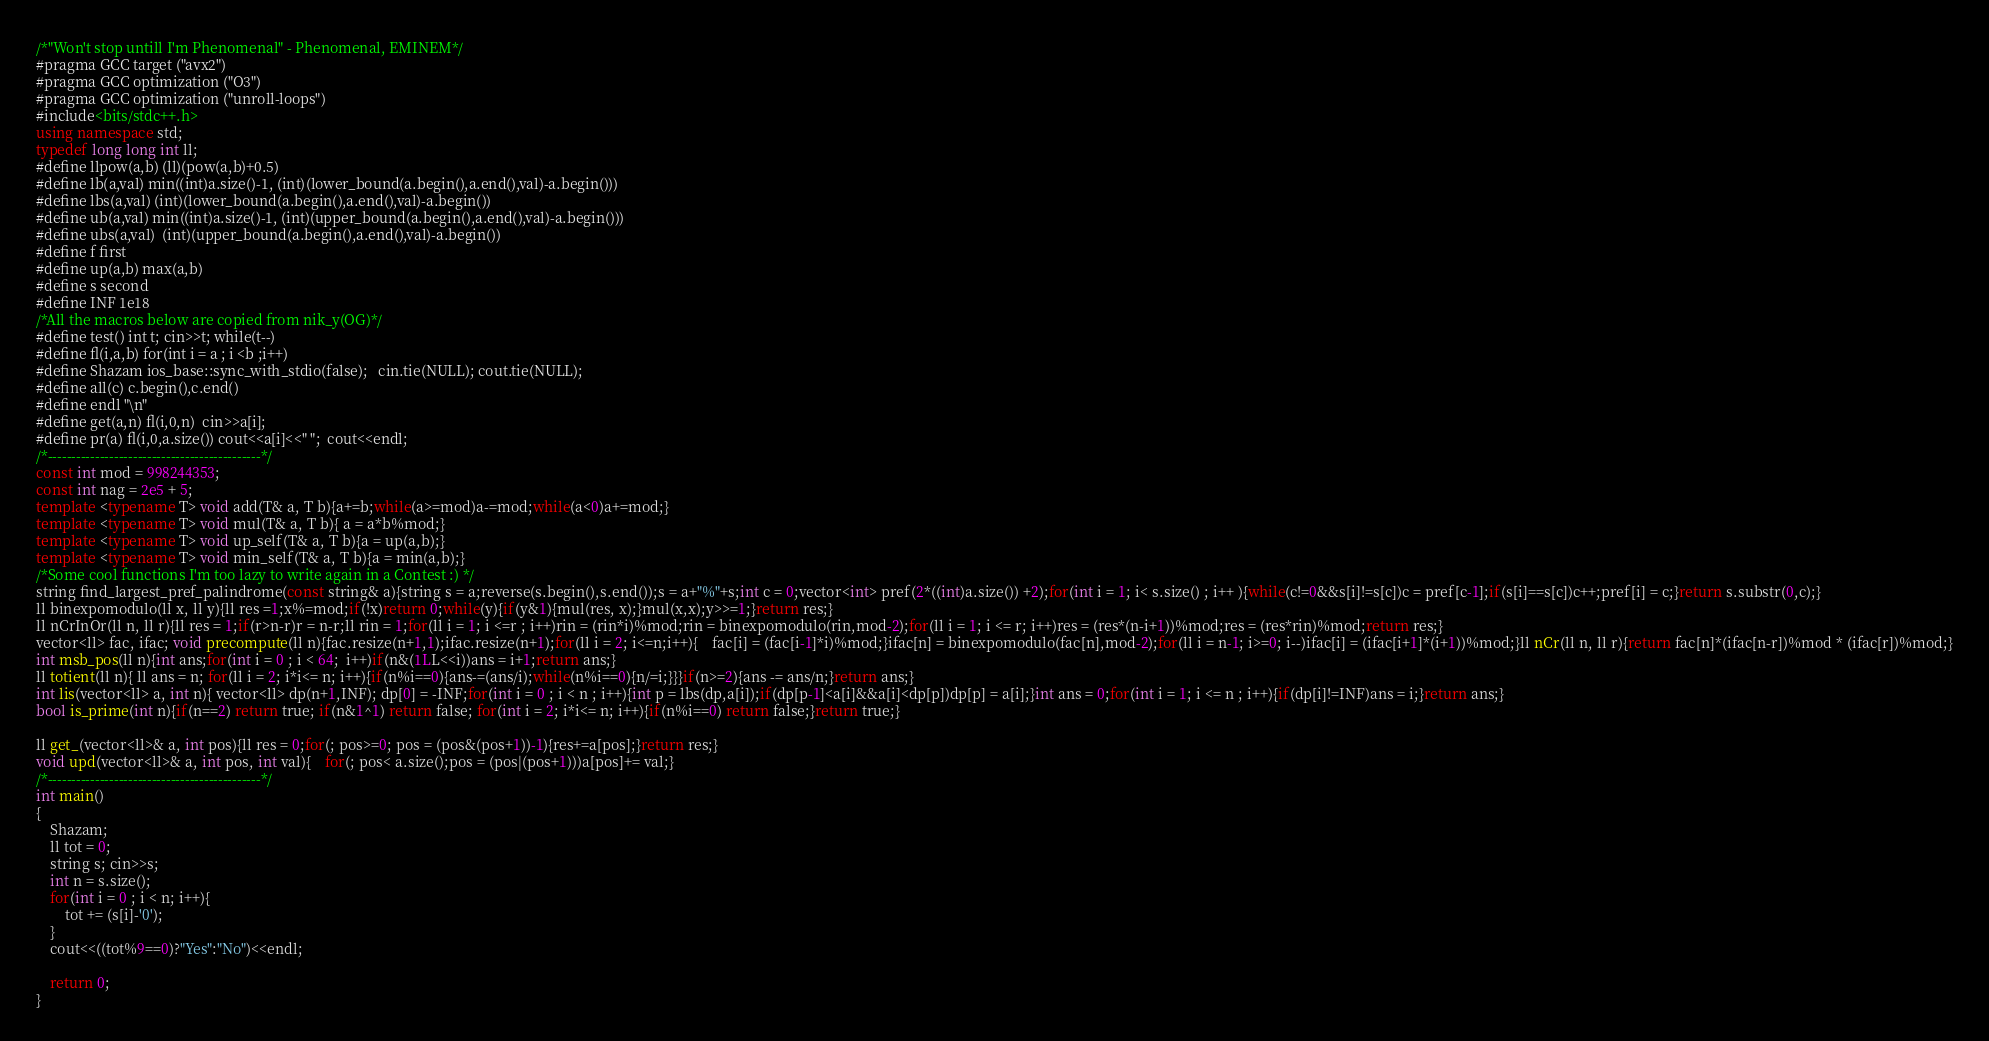Convert code to text. <code><loc_0><loc_0><loc_500><loc_500><_C++_>/*"Won't stop untill I'm Phenomenal" - Phenomenal, EMINEM*/
#pragma GCC target ("avx2")
#pragma GCC optimization ("O3")
#pragma GCC optimization ("unroll-loops")
#include<bits/stdc++.h>
using namespace std;
typedef long long int ll;
#define llpow(a,b) (ll)(pow(a,b)+0.5)
#define lb(a,val) min((int)a.size()-1, (int)(lower_bound(a.begin(),a.end(),val)-a.begin()))
#define lbs(a,val) (int)(lower_bound(a.begin(),a.end(),val)-a.begin())
#define ub(a,val) min((int)a.size()-1, (int)(upper_bound(a.begin(),a.end(),val)-a.begin()))
#define ubs(a,val)  (int)(upper_bound(a.begin(),a.end(),val)-a.begin())
#define f first
#define up(a,b) max(a,b)
#define s second
#define INF 1e18
/*All the macros below are copied from nik_y(OG)*/
#define test() int t; cin>>t; while(t--)
#define fl(i,a,b) for(int i = a ; i <b ;i++)
#define Shazam ios_base::sync_with_stdio(false);   cin.tie(NULL); cout.tie(NULL);
#define all(c) c.begin(),c.end()
#define endl "\n"
#define get(a,n) fl(i,0,n)  cin>>a[i];
#define pr(a) fl(i,0,a.size()) cout<<a[i]<<" ";	cout<<endl;
/*---------------------------------------------*/
const int mod = 998244353;
const int nag = 2e5 + 5;
template <typename T> void add(T& a, T b){a+=b;while(a>=mod)a-=mod;while(a<0)a+=mod;}
template <typename T> void mul(T& a, T b){ a = a*b%mod;}
template <typename T> void up_self(T& a, T b){a = up(a,b);}
template <typename T> void min_self(T& a, T b){a = min(a,b);}
/*Some cool functions I'm too lazy to write again in a Contest :) */
string find_largest_pref_palindrome(const string& a){string s = a;reverse(s.begin(),s.end());s = a+"%"+s;int c = 0;vector<int> pref(2*((int)a.size()) +2);for(int i = 1; i< s.size() ; i++ ){while(c!=0&&s[i]!=s[c])c = pref[c-1];if(s[i]==s[c])c++;pref[i] = c;}return s.substr(0,c);}
ll binexpomodulo(ll x, ll y){ll res =1;x%=mod;if(!x)return 0;while(y){if(y&1){mul(res, x);}mul(x,x);y>>=1;}return res;}
ll nCrInOr(ll n, ll r){ll res = 1;if(r>n-r)r = n-r;ll rin = 1;for(ll i = 1; i <=r ; i++)rin = (rin*i)%mod;rin = binexpomodulo(rin,mod-2);for(ll i = 1; i <= r; i++)res = (res*(n-i+1))%mod;res = (res*rin)%mod;return res;}
vector<ll> fac, ifac; void precompute(ll n){fac.resize(n+1,1);ifac.resize(n+1);for(ll i = 2; i<=n;i++){	fac[i] = (fac[i-1]*i)%mod;}ifac[n] = binexpomodulo(fac[n],mod-2);for(ll i = n-1; i>=0; i--)ifac[i] = (ifac[i+1]*(i+1))%mod;}ll nCr(ll n, ll r){return fac[n]*(ifac[n-r])%mod * (ifac[r])%mod;}
int msb_pos(ll n){int ans;for(int i = 0 ; i < 64;  i++)if(n&(1LL<<i))ans = i+1;return ans;}
ll totient(ll n){ ll ans = n; for(ll i = 2; i*i<= n; i++){if(n%i==0){ans-=(ans/i);while(n%i==0){n/=i;}}}if(n>=2){ans -= ans/n;}return ans;}
int lis(vector<ll> a, int n){ vector<ll> dp(n+1,INF); dp[0] = -INF;for(int i = 0 ; i < n ; i++){int p = lbs(dp,a[i]);if(dp[p-1]<a[i]&&a[i]<dp[p])dp[p] = a[i];}int ans = 0;for(int i = 1; i <= n ; i++){if(dp[i]!=INF)ans = i;}return ans;}
bool is_prime(int n){if(n==2) return true; if(n&1^1) return false; for(int i = 2; i*i<= n; i++){if(n%i==0) return false;}return true;}

ll get_(vector<ll>& a, int pos){ll res = 0;for(; pos>=0; pos = (pos&(pos+1))-1){res+=a[pos];}return res;}
void upd(vector<ll>& a, int pos, int val){	for(; pos< a.size();pos = (pos|(pos+1)))a[pos]+= val;}
/*---------------------------------------------*/
int main()
{
	Shazam;
	ll tot = 0;
	string s; cin>>s;
	int n = s.size();
	for(int i = 0 ; i < n; i++){
		tot += (s[i]-'0');
	}
	cout<<((tot%9==0)?"Yes":"No")<<endl;
	
	return 0;
}</code> 